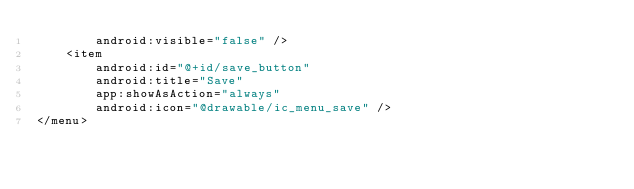<code> <loc_0><loc_0><loc_500><loc_500><_XML_>        android:visible="false" />
    <item
        android:id="@+id/save_button"
        android:title="Save"
        app:showAsAction="always"
        android:icon="@drawable/ic_menu_save" />
</menu></code> 